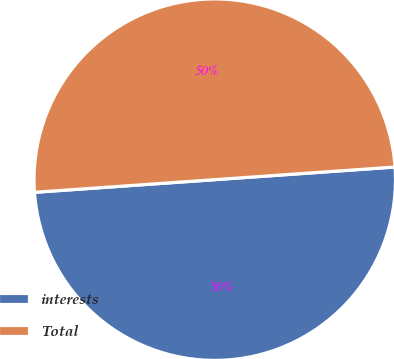Convert chart to OTSL. <chart><loc_0><loc_0><loc_500><loc_500><pie_chart><fcel>interests<fcel>Total<nl><fcel>50.0%<fcel>50.0%<nl></chart> 